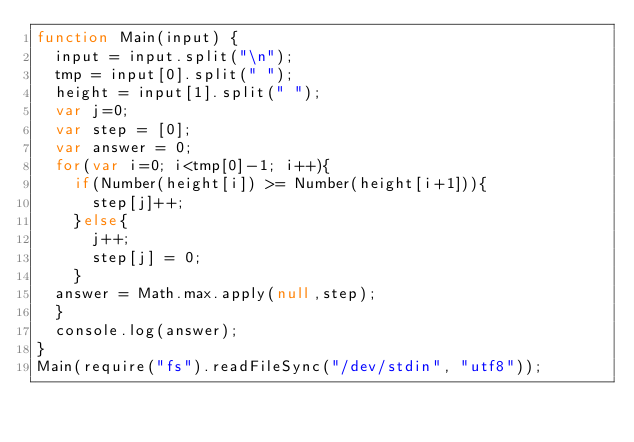<code> <loc_0><loc_0><loc_500><loc_500><_JavaScript_>function Main(input) {
  input = input.split("\n");
  tmp = input[0].split(" ");
  height = input[1].split(" ");
  var j=0;
  var step = [0];
  var answer = 0;
  for(var i=0; i<tmp[0]-1; i++){
    if(Number(height[i]) >= Number(height[i+1])){
      step[j]++;
    }else{
      j++;
      step[j] = 0;
    }
  answer = Math.max.apply(null,step);
  }
  console.log(answer);
}
Main(require("fs").readFileSync("/dev/stdin", "utf8"));</code> 